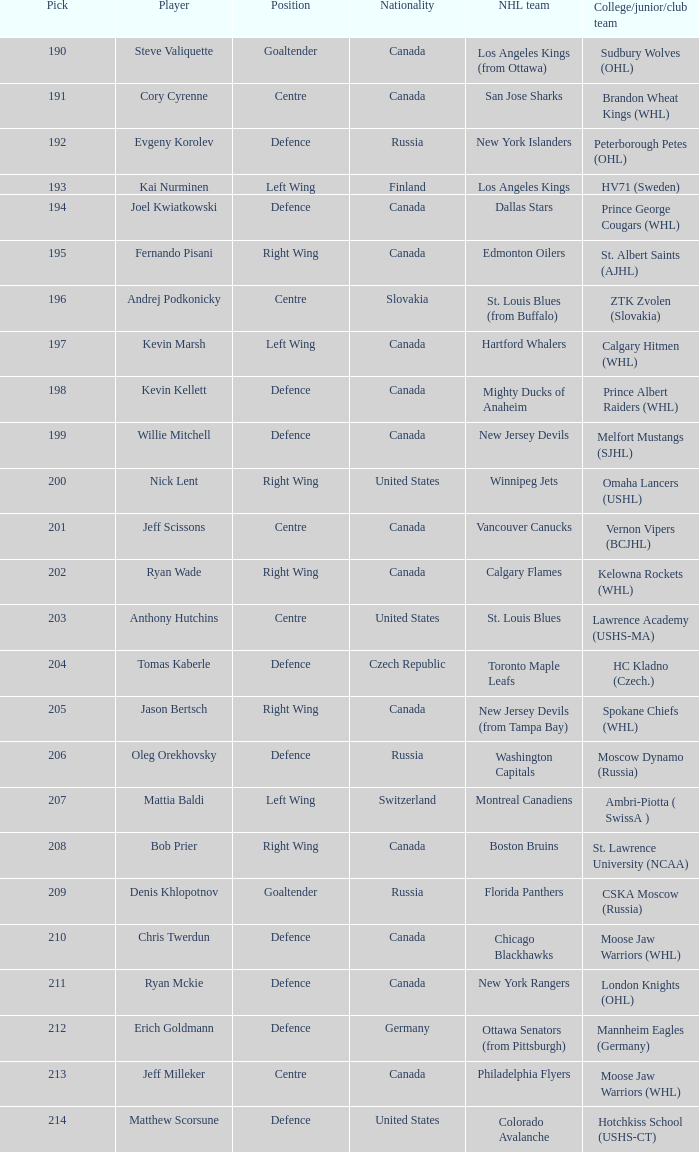What is the prime selection for evgeny korolev? 192.0. 